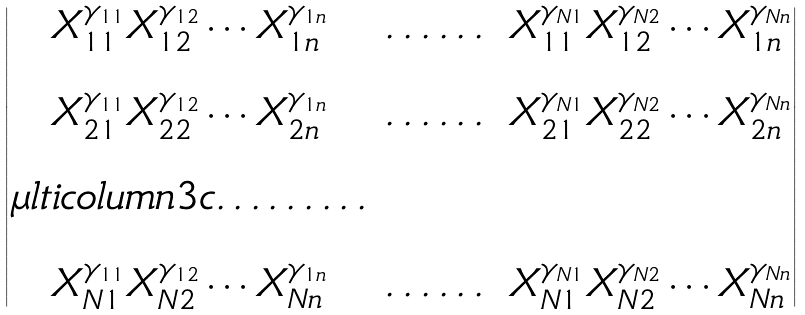Convert formula to latex. <formula><loc_0><loc_0><loc_500><loc_500>\begin{vmatrix} X _ { 1 1 } ^ { \gamma _ { 1 1 } } X _ { 1 2 } ^ { \gamma _ { 1 2 } } \cdots X _ { 1 n } ^ { \gamma _ { 1 n } } & \dots \dots & X _ { 1 1 } ^ { \gamma _ { N 1 } } X _ { 1 2 } ^ { \gamma _ { N 2 } } \cdots X _ { 1 n } ^ { \gamma _ { N n } } \\ \\ X _ { 2 1 } ^ { \gamma _ { 1 1 } } X _ { 2 2 } ^ { \gamma _ { 1 2 } } \cdots X _ { 2 n } ^ { \gamma _ { 1 n } } & \dots \dots & X _ { 2 1 } ^ { \gamma _ { N 1 } } X _ { 2 2 } ^ { \gamma _ { N 2 } } \cdots X _ { 2 n } ^ { \gamma _ { N n } } \\ \\ \mu l t i c o l u m n { 3 } { c } { \dots \dots \dots } \\ \\ X _ { N 1 } ^ { \gamma _ { 1 1 } } X _ { N 2 } ^ { \gamma _ { 1 2 } } \cdots X _ { N n } ^ { \gamma _ { 1 n } } & \dots \dots & X _ { N 1 } ^ { \gamma _ { N 1 } } X _ { N 2 } ^ { \gamma _ { N 2 } } \cdots X _ { N n } ^ { \gamma _ { N n } } \end{vmatrix}</formula> 